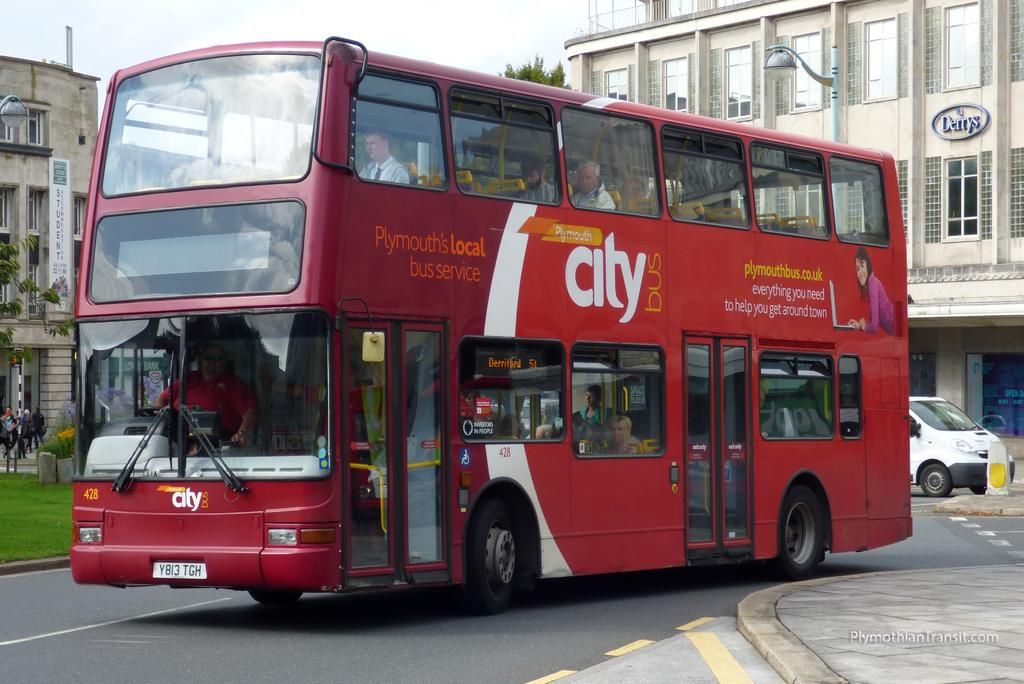<image>
Relay a brief, clear account of the picture shown. Red double decker bus  that says "Plymouth's local bus service" heading down a street. 